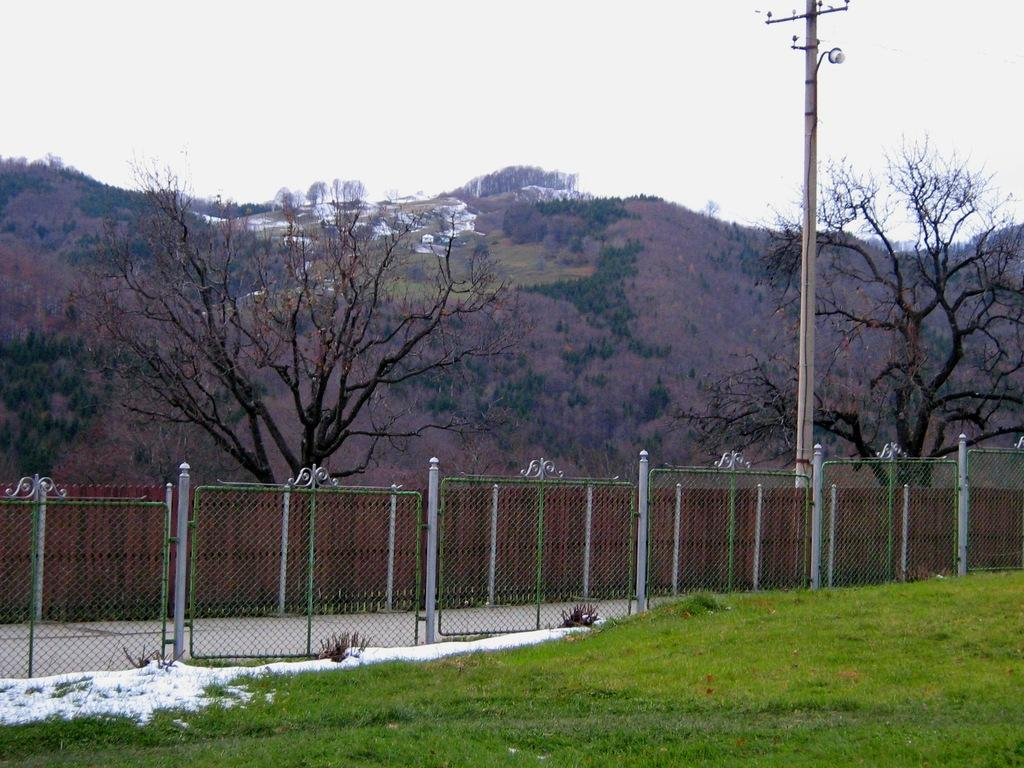What type of vegetation is present in the image? There is grass in the image. What structure can be seen in the image? There is a fence in the image. What object is standing upright in the image? There is a pole in the image. What type of plants are visible in the image besides grass? There are trees in the image. Where are the houses located in the image? The houses are on top of a hill in the image. How many legs can be seen on the cast in the image? There is no cast present in the image. What type of birds are flying over the houses in the image? There are no birds visible in the image; it only shows houses on a hill. 